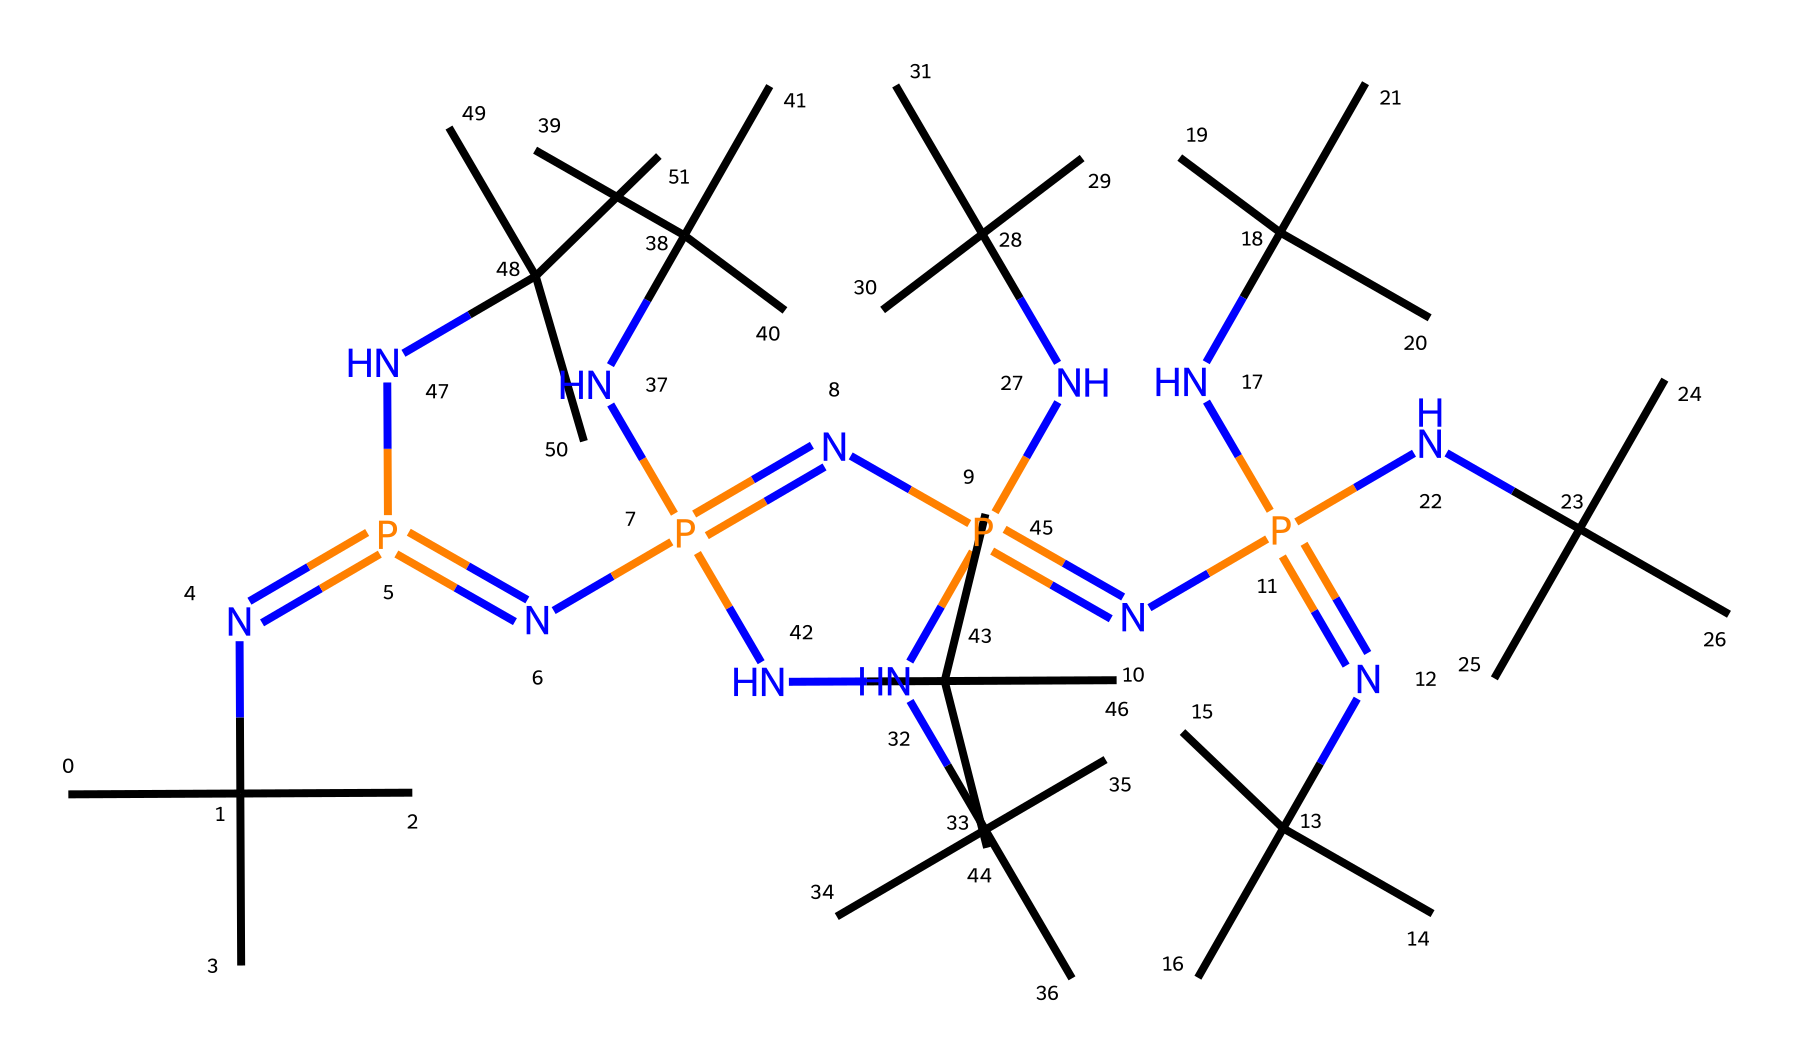What is the total number of nitrogen atoms in this molecule? By examining the SMILES representation, you can count the number of nitrogen (N) atoms, which appear in the sequence. Each "N" represents a nitrogen atom, and there are a total of six nitrogen atoms present.
Answer: six How many tert-butyl groups (C(C)(C)C) are attached in this structure? The structure contains multiple occurrences of the tert-butyl group, which can be identified by counting instances of "C(C)(C)C" in the SMILES representation. There are five such groups attached in the overall structure.
Answer: five What type of bonding character is predominant in phosphazenes? Phosphazenes are characterized by a significant amount of multiple nitrogen-phosphorus bonds, which feature both covalent bonding and double bond character, particularly with the presence of alternating double bonds between nitrogen and phosphorus in the SMILES.
Answer: covalent What is the core unit that defines this class of superbases? The chemical structure consists of a phosphorus atom alternated with nitrogen atoms, which is a defining feature of phosphazenes, leading to their classification as superbases. This arrangement contributes to the overall structure's high basicity.
Answer: phosphorus-nitrogen unit What is the hybridization state of the phosphorus atoms in this compound? In phosphazenes like this, the phosphorus atoms typically exhibit sp2 hybridization due to the bond angles and bonding partners, which can be inferred from the molecular structure derived from the SMILES representation.
Answer: sp2 How does the presence of nitrogen atoms contribute to the basicity of this compound? The nitrogen atoms in the structure act as proton acceptors due to their lone pairs, greatly increasing the compound's basicity. This behavior comes from the combination of N-H bond formation and resonance stabilization from the P-N connectivity.
Answer: increases basicity 